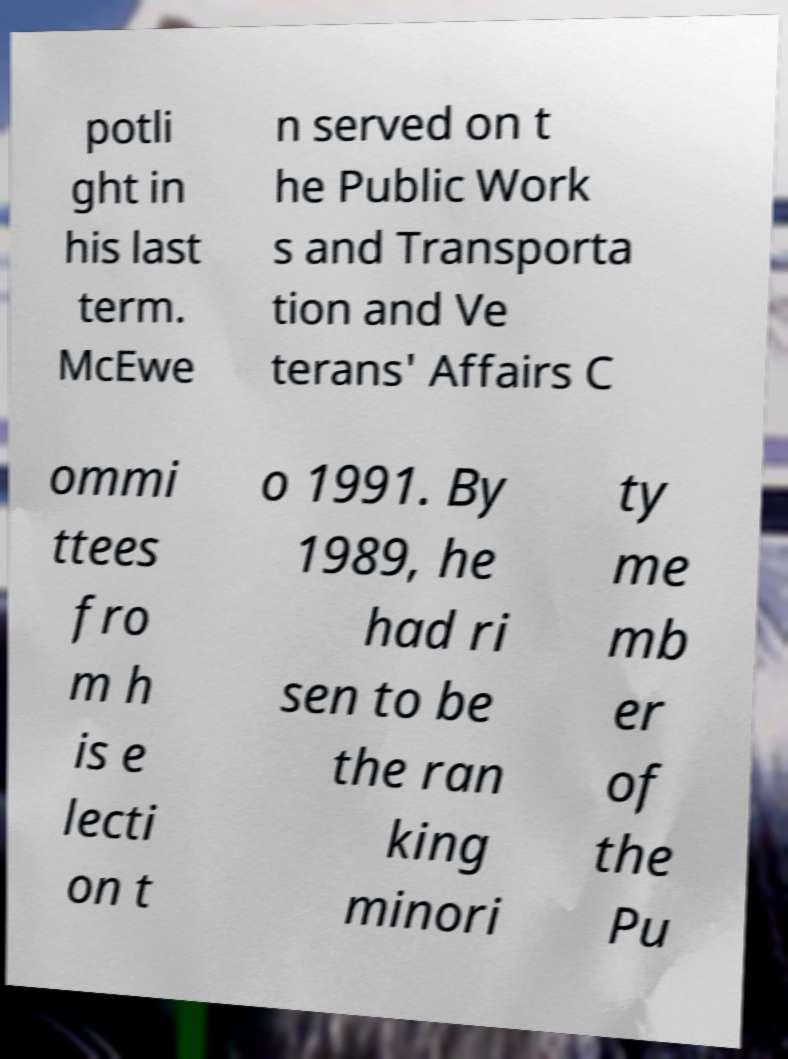Can you accurately transcribe the text from the provided image for me? potli ght in his last term. McEwe n served on t he Public Work s and Transporta tion and Ve terans' Affairs C ommi ttees fro m h is e lecti on t o 1991. By 1989, he had ri sen to be the ran king minori ty me mb er of the Pu 